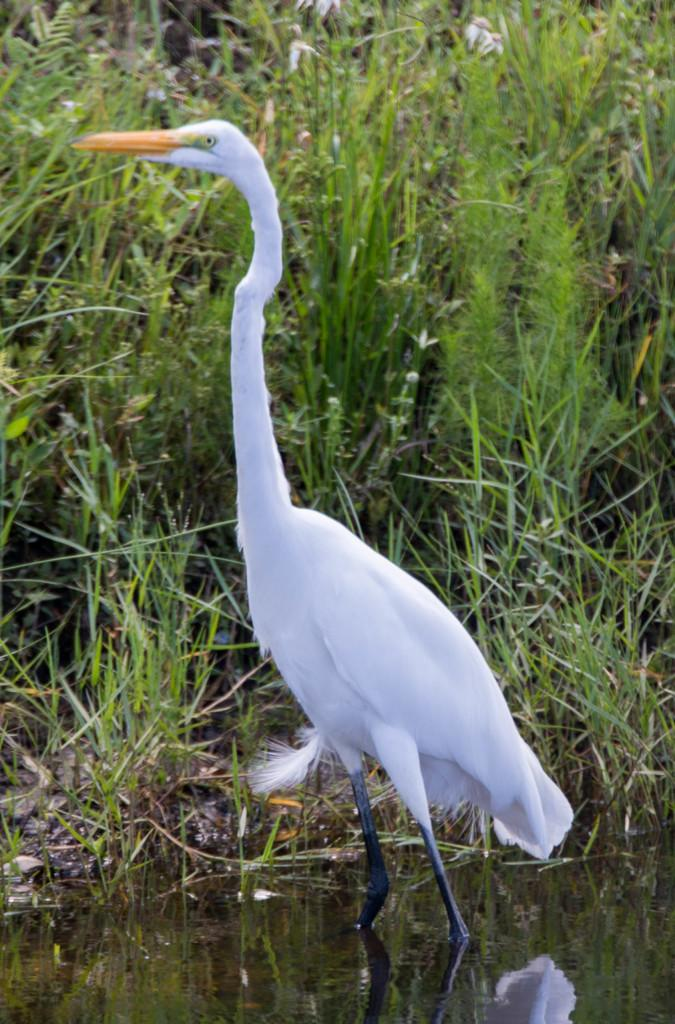What is located in the water in the image? There is a crane in the water. What type of vegetation can be seen in the background of the image? There is grass visible in the background of the image. What type of coal is being carried by the pet in the image? There is no pet or coal present in the image; it features a crane in the water and grass in the background. 